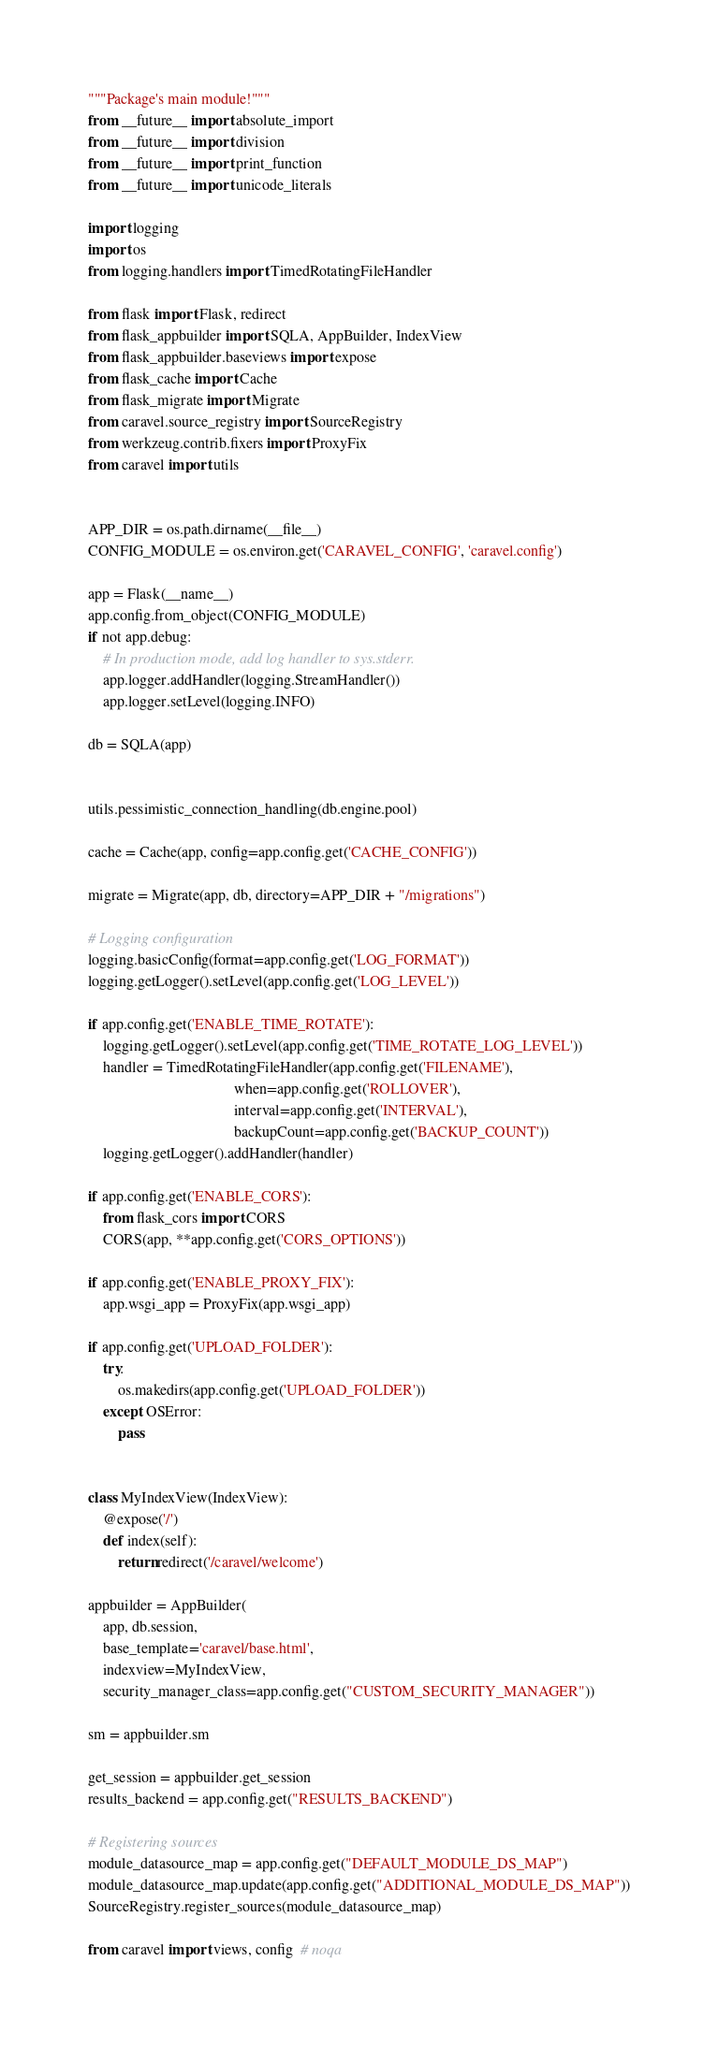<code> <loc_0><loc_0><loc_500><loc_500><_Python_>"""Package's main module!"""
from __future__ import absolute_import
from __future__ import division
from __future__ import print_function
from __future__ import unicode_literals

import logging
import os
from logging.handlers import TimedRotatingFileHandler

from flask import Flask, redirect
from flask_appbuilder import SQLA, AppBuilder, IndexView
from flask_appbuilder.baseviews import expose
from flask_cache import Cache
from flask_migrate import Migrate
from caravel.source_registry import SourceRegistry
from werkzeug.contrib.fixers import ProxyFix
from caravel import utils


APP_DIR = os.path.dirname(__file__)
CONFIG_MODULE = os.environ.get('CARAVEL_CONFIG', 'caravel.config')

app = Flask(__name__)
app.config.from_object(CONFIG_MODULE)
if not app.debug:
    # In production mode, add log handler to sys.stderr.
    app.logger.addHandler(logging.StreamHandler())
    app.logger.setLevel(logging.INFO)

db = SQLA(app)


utils.pessimistic_connection_handling(db.engine.pool)

cache = Cache(app, config=app.config.get('CACHE_CONFIG'))

migrate = Migrate(app, db, directory=APP_DIR + "/migrations")

# Logging configuration
logging.basicConfig(format=app.config.get('LOG_FORMAT'))
logging.getLogger().setLevel(app.config.get('LOG_LEVEL'))

if app.config.get('ENABLE_TIME_ROTATE'):
    logging.getLogger().setLevel(app.config.get('TIME_ROTATE_LOG_LEVEL'))
    handler = TimedRotatingFileHandler(app.config.get('FILENAME'),
                                       when=app.config.get('ROLLOVER'),
                                       interval=app.config.get('INTERVAL'),
                                       backupCount=app.config.get('BACKUP_COUNT'))
    logging.getLogger().addHandler(handler)

if app.config.get('ENABLE_CORS'):
    from flask_cors import CORS
    CORS(app, **app.config.get('CORS_OPTIONS'))

if app.config.get('ENABLE_PROXY_FIX'):
    app.wsgi_app = ProxyFix(app.wsgi_app)

if app.config.get('UPLOAD_FOLDER'):
    try:
        os.makedirs(app.config.get('UPLOAD_FOLDER'))
    except OSError:
        pass


class MyIndexView(IndexView):
    @expose('/')
    def index(self):
        return redirect('/caravel/welcome')

appbuilder = AppBuilder(
    app, db.session,
    base_template='caravel/base.html',
    indexview=MyIndexView,
    security_manager_class=app.config.get("CUSTOM_SECURITY_MANAGER"))

sm = appbuilder.sm

get_session = appbuilder.get_session
results_backend = app.config.get("RESULTS_BACKEND")

# Registering sources
module_datasource_map = app.config.get("DEFAULT_MODULE_DS_MAP")
module_datasource_map.update(app.config.get("ADDITIONAL_MODULE_DS_MAP"))
SourceRegistry.register_sources(module_datasource_map)

from caravel import views, config  # noqa
</code> 